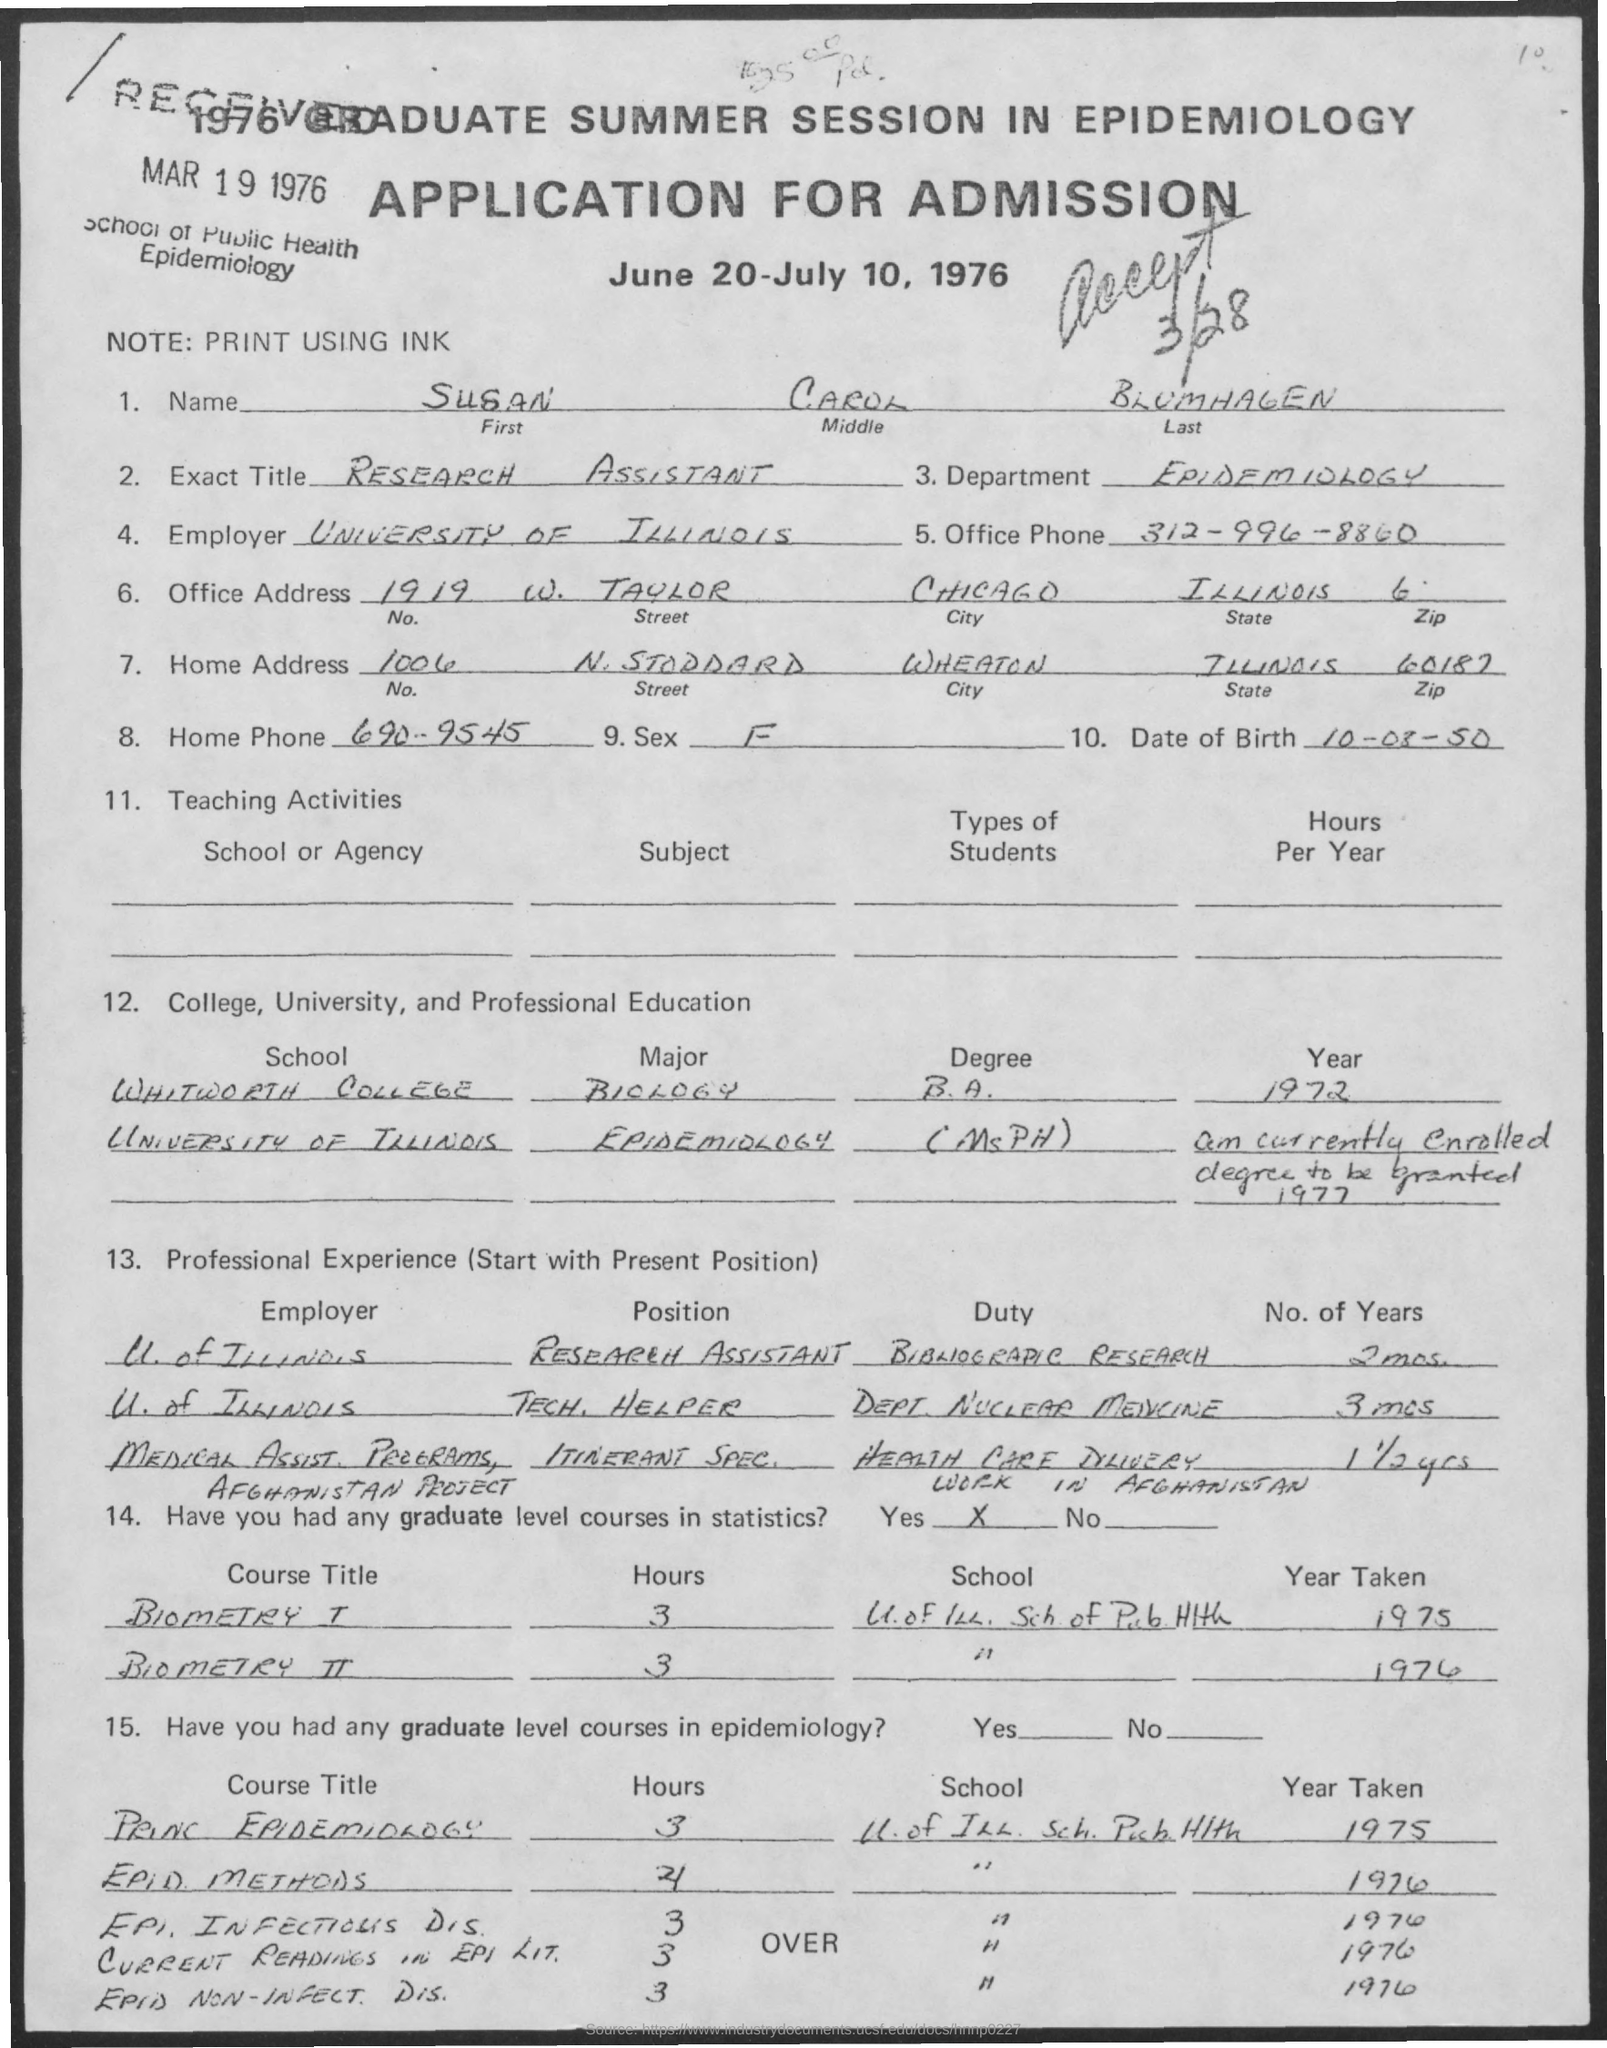Highlight a few significant elements in this photo. The name "Susan" is mentioned in the given application. The department mentioned in the given application is called Epidemiology. The middle name as mentioned in the given application is "Carol. The sex mentioned in the given application is female. The exact title mentioned in the given application is "Research Assistant. 